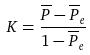Convert formula to latex. <formula><loc_0><loc_0><loc_500><loc_500>K = \frac { \overline { P } - \overline { P } _ { e } } { 1 - \overline { P } _ { e } }</formula> 